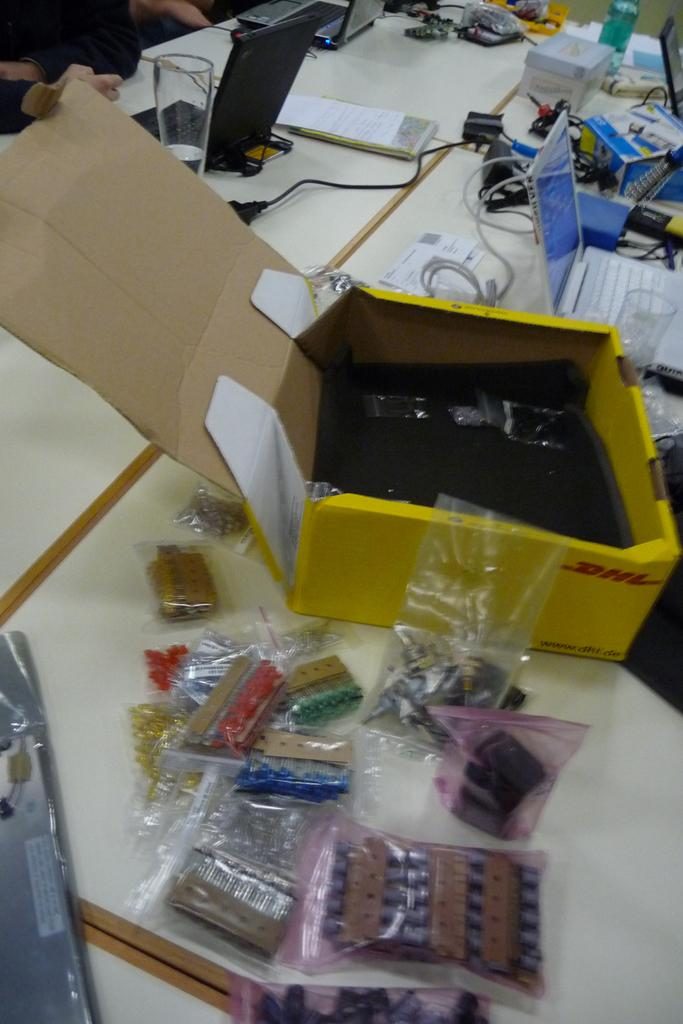What is on the table in the image? There is a cardboard box, laptops, books, a glass, a bottle, cables, and papers on the table in the image. Can you describe the electronic devices on the table? There are laptops on the table. What type of container is on the table? There is a cardboard box on the table. What might be used for drinking or holding a beverage? There is a glass on the table. What might be used for holding a liquid? There is a bottle on the table. What might be used for connecting devices? There are cables on the table. What might be used for writing or reading? There are books and papers on the table. Can you see any clouds in the image? There are no clouds visible in the image; it is an indoor scene. 